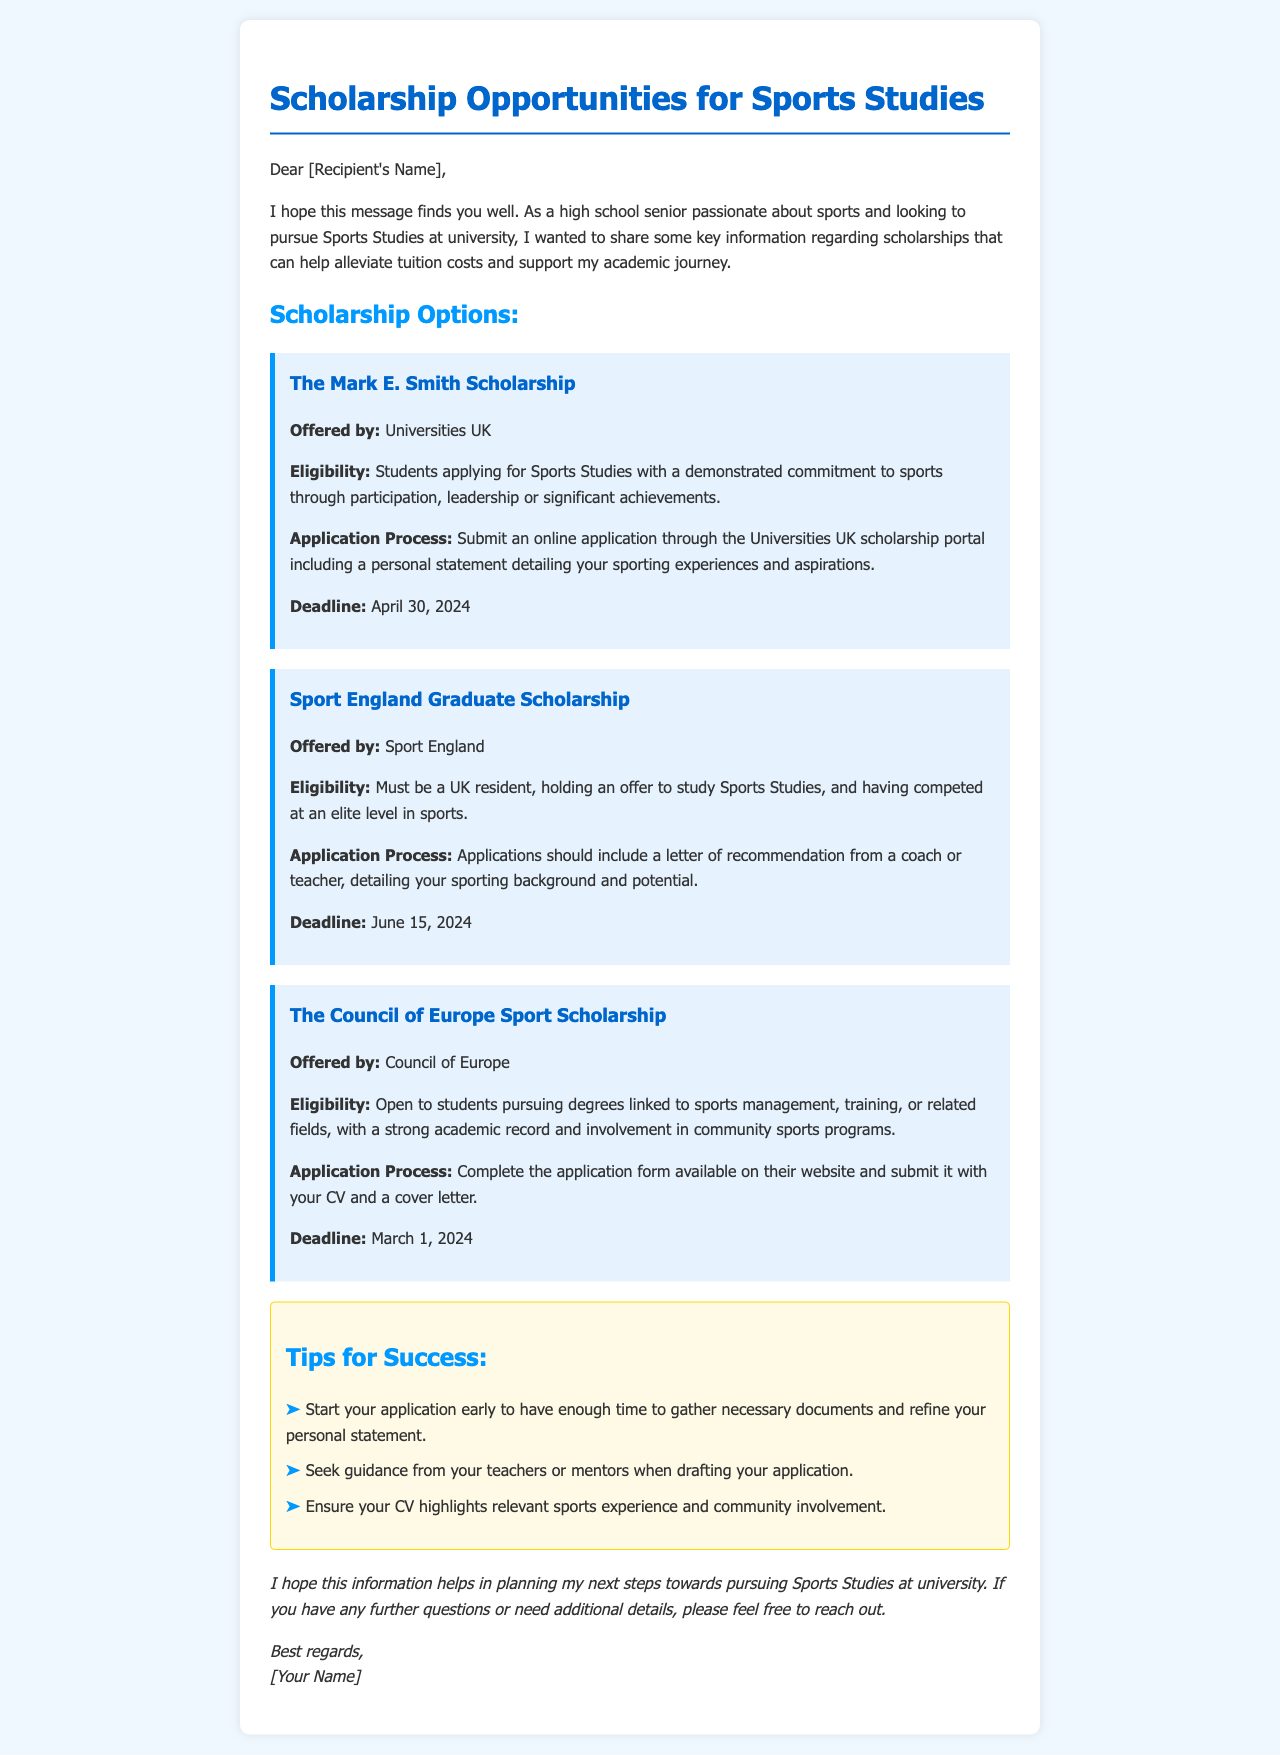What is the first scholarship listed? The first scholarship mentioned in the document is The Mark E. Smith Scholarship.
Answer: The Mark E. Smith Scholarship Who offers the Sport England Graduate Scholarship? The document states that the Sport England Graduate Scholarship is offered by Sport England.
Answer: Sport England What is the deadline for the Council of Europe Sport Scholarship? The document specifies that the deadline for this scholarship is March 1, 2024.
Answer: March 1, 2024 What is one eligibility criterion for The Mark E. Smith Scholarship? The eligibility criterion includes a demonstrated commitment to sports through participation, leadership or significant achievements.
Answer: Commitment to sports What must be included in the application for the Sport England Graduate Scholarship? The application must include a letter of recommendation from a coach or teacher, detailing the applicant's sporting background and potential.
Answer: Letter of recommendation What should applicants highlight in their CV? According to the tips provided, applicants should ensure their CV highlights relevant sports experience and community involvement.
Answer: Relevant sports experience How many scholarships are mentioned in total? The document discusses three different scholarships available for Sports Studies.
Answer: Three What type of document is this? The content is structured as an email sharing information on scholarship opportunities.
Answer: Email What is one of the tips for success mentioned in the email? One of the tips is to start the application early to have enough time to gather necessary documents and refine the personal statement.
Answer: Start your application early 